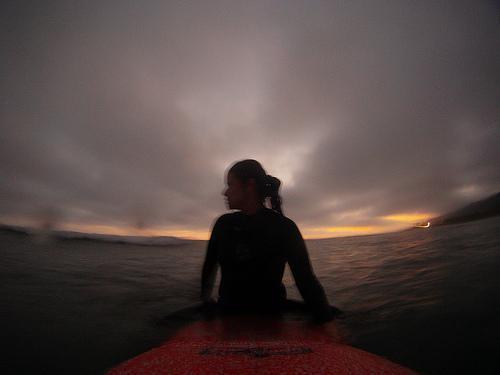How many surfers are in the picture?
Give a very brief answer. 1. 